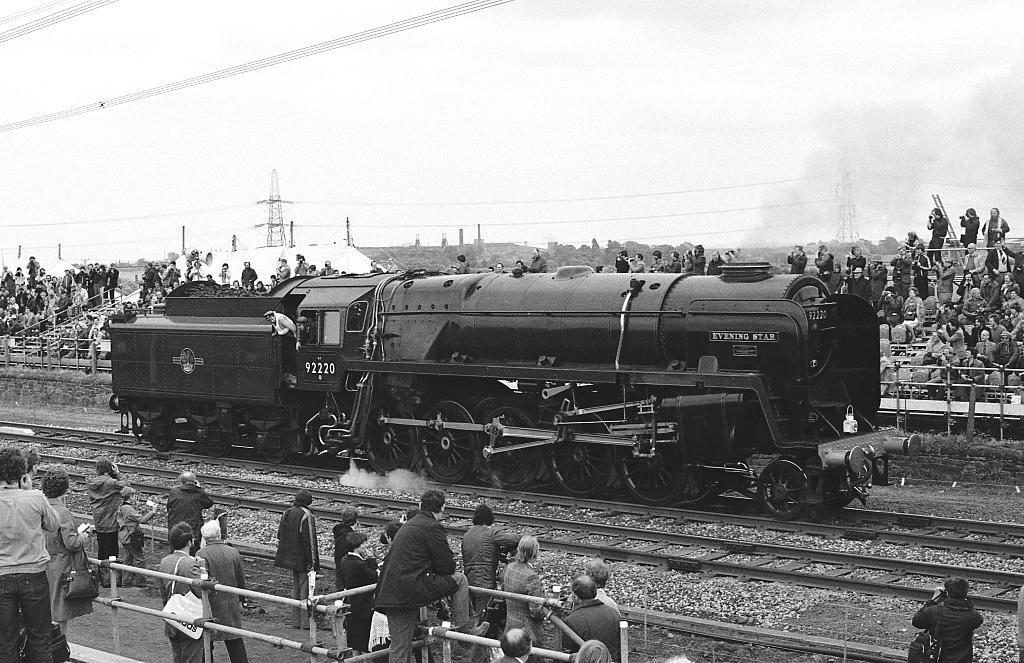What is the main subject of the image? The main subject of the image is a train. Where is the train located in the image? The train is on a railway track. What can be seen in the background of the image? There are persons visible in the background of the image, and the sky is also visible. What type of oatmeal is being served to the passengers in the train? There is no indication of oatmeal or passengers being served food in the image. Can you see a pump in the image? There is no pump visible in the image. 